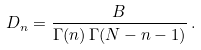Convert formula to latex. <formula><loc_0><loc_0><loc_500><loc_500>D _ { n } = \frac { B } { \Gamma ( n ) \, \Gamma ( N - n - 1 ) } \, .</formula> 